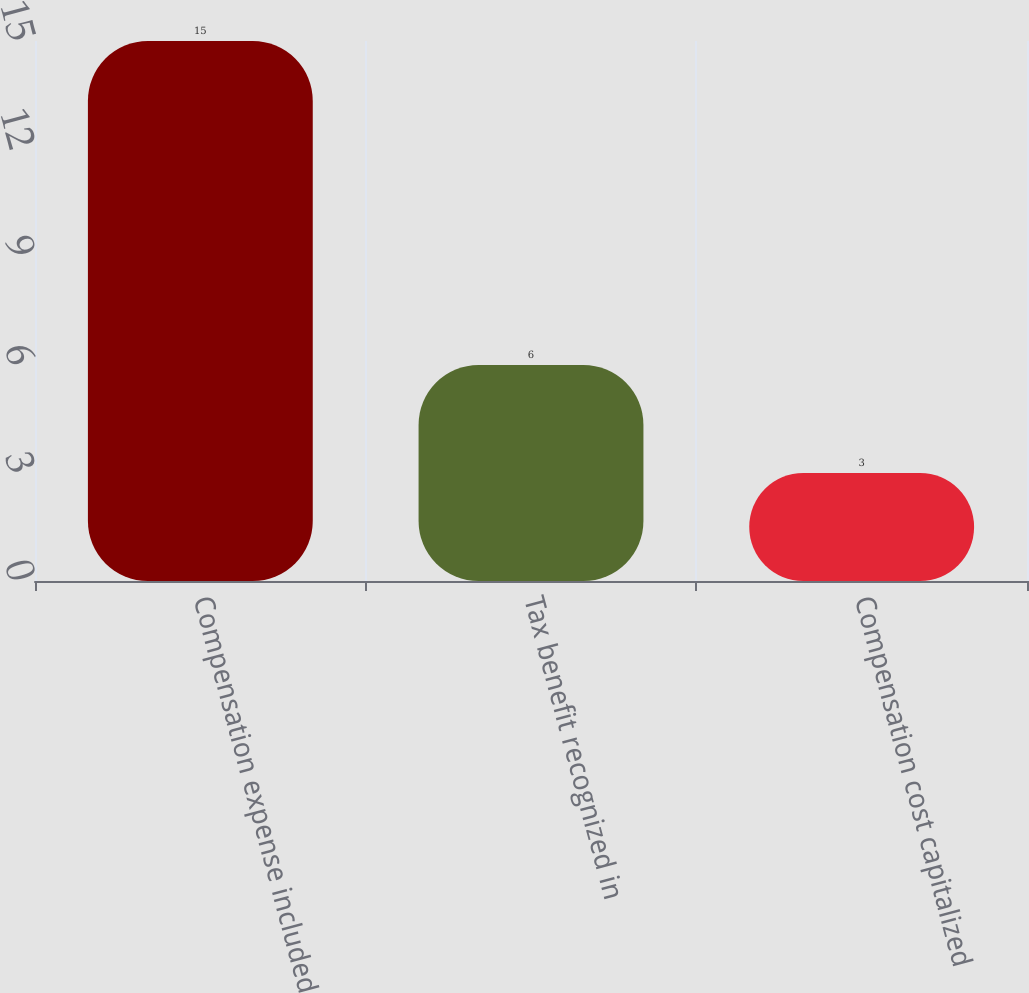<chart> <loc_0><loc_0><loc_500><loc_500><bar_chart><fcel>Compensation expense included<fcel>Tax benefit recognized in<fcel>Compensation cost capitalized<nl><fcel>15<fcel>6<fcel>3<nl></chart> 